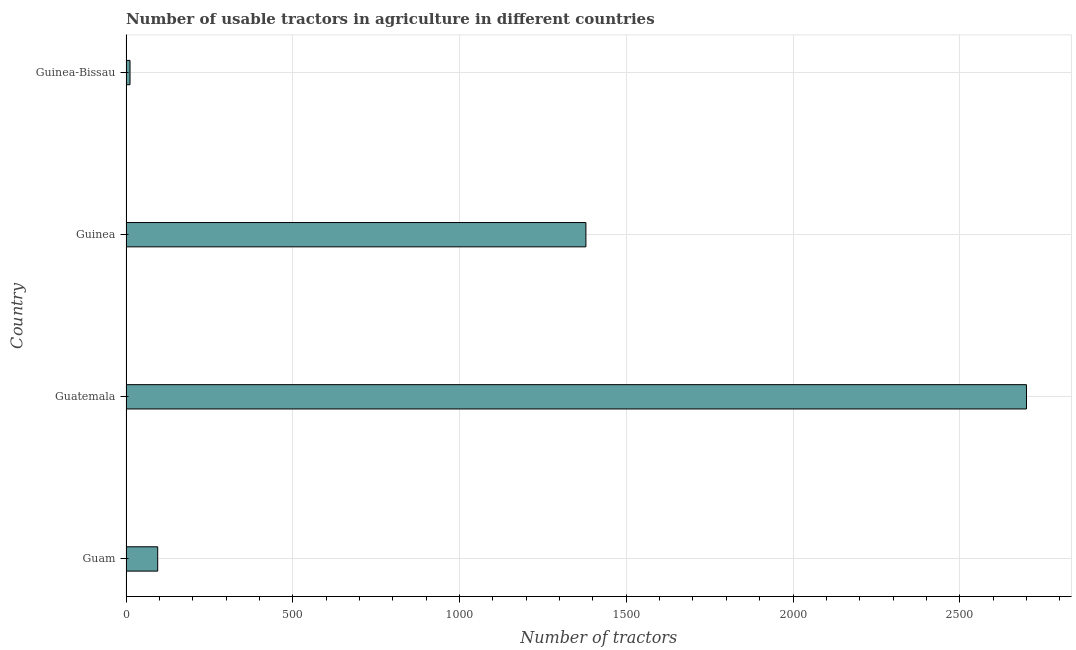Does the graph contain any zero values?
Provide a short and direct response. No. What is the title of the graph?
Your response must be concise. Number of usable tractors in agriculture in different countries. What is the label or title of the X-axis?
Your answer should be very brief. Number of tractors. What is the label or title of the Y-axis?
Give a very brief answer. Country. Across all countries, what is the maximum number of tractors?
Provide a short and direct response. 2700. Across all countries, what is the minimum number of tractors?
Keep it short and to the point. 12. In which country was the number of tractors maximum?
Offer a terse response. Guatemala. In which country was the number of tractors minimum?
Offer a terse response. Guinea-Bissau. What is the sum of the number of tractors?
Provide a succinct answer. 4186. What is the average number of tractors per country?
Provide a succinct answer. 1046. What is the median number of tractors?
Provide a succinct answer. 737. In how many countries, is the number of tractors greater than 100 ?
Offer a very short reply. 2. What is the ratio of the number of tractors in Guam to that in Guinea?
Your answer should be very brief. 0.07. Is the number of tractors in Guinea less than that in Guinea-Bissau?
Offer a very short reply. No. What is the difference between the highest and the second highest number of tractors?
Your answer should be very brief. 1321. What is the difference between the highest and the lowest number of tractors?
Ensure brevity in your answer.  2688. In how many countries, is the number of tractors greater than the average number of tractors taken over all countries?
Your answer should be compact. 2. How many bars are there?
Your answer should be compact. 4. What is the difference between two consecutive major ticks on the X-axis?
Your answer should be very brief. 500. What is the Number of tractors in Guatemala?
Provide a short and direct response. 2700. What is the Number of tractors in Guinea?
Provide a succinct answer. 1379. What is the difference between the Number of tractors in Guam and Guatemala?
Your answer should be very brief. -2605. What is the difference between the Number of tractors in Guam and Guinea?
Provide a succinct answer. -1284. What is the difference between the Number of tractors in Guatemala and Guinea?
Your response must be concise. 1321. What is the difference between the Number of tractors in Guatemala and Guinea-Bissau?
Your answer should be very brief. 2688. What is the difference between the Number of tractors in Guinea and Guinea-Bissau?
Provide a short and direct response. 1367. What is the ratio of the Number of tractors in Guam to that in Guatemala?
Ensure brevity in your answer.  0.04. What is the ratio of the Number of tractors in Guam to that in Guinea?
Offer a very short reply. 0.07. What is the ratio of the Number of tractors in Guam to that in Guinea-Bissau?
Your answer should be compact. 7.92. What is the ratio of the Number of tractors in Guatemala to that in Guinea?
Provide a short and direct response. 1.96. What is the ratio of the Number of tractors in Guatemala to that in Guinea-Bissau?
Make the answer very short. 225. What is the ratio of the Number of tractors in Guinea to that in Guinea-Bissau?
Your answer should be very brief. 114.92. 